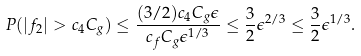<formula> <loc_0><loc_0><loc_500><loc_500>P ( | f _ { 2 } | > c _ { 4 } C _ { g } ) \leq \frac { ( 3 / 2 ) c _ { 4 } C _ { g } \epsilon } { c _ { f } C _ { g } \epsilon ^ { 1 / 3 } } \leq \frac { 3 } { 2 } \epsilon ^ { 2 / 3 } \leq \frac { 3 } { 2 } \epsilon ^ { 1 / 3 } .</formula> 